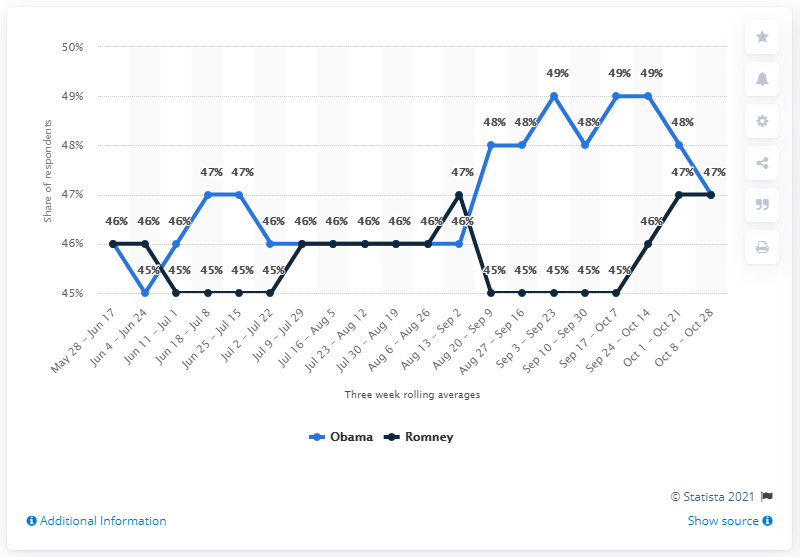Identify some key points in this picture. Out of the 9 periods analyzed, 45% of voters supported Mitt Romney. There are 7 periods in total, and they all have the same number of supporters for both of them. 